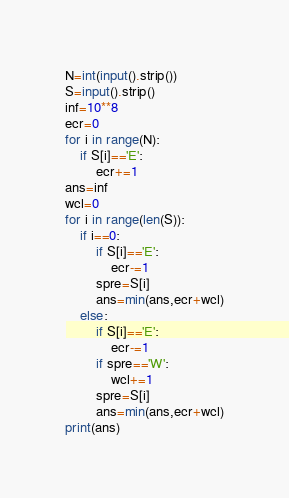<code> <loc_0><loc_0><loc_500><loc_500><_Python_>N=int(input().strip())
S=input().strip()
inf=10**8
ecr=0
for i in range(N):
    if S[i]=='E':
        ecr+=1
ans=inf
wcl=0
for i in range(len(S)):
    if i==0:
        if S[i]=='E':
            ecr-=1
        spre=S[i]
        ans=min(ans,ecr+wcl)
    else:
        if S[i]=='E':
            ecr-=1
        if spre=='W':
            wcl+=1
        spre=S[i]
        ans=min(ans,ecr+wcl)
print(ans)</code> 